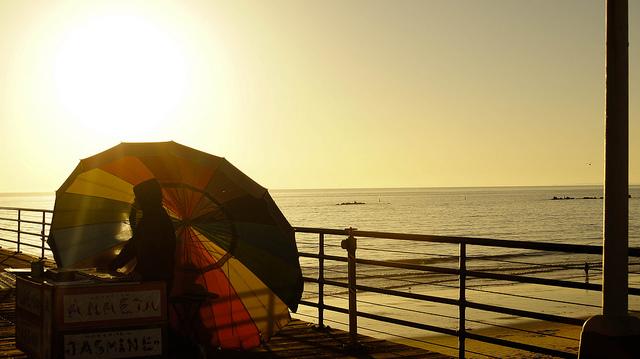What is the man holding?
Quick response, please. Umbrella. Where is he?
Keep it brief. Beach. Who is holding the umbrella?
Short answer required. Man. Is the weather hot?
Concise answer only. Yes. Is this a sunny day?
Short answer required. Yes. 